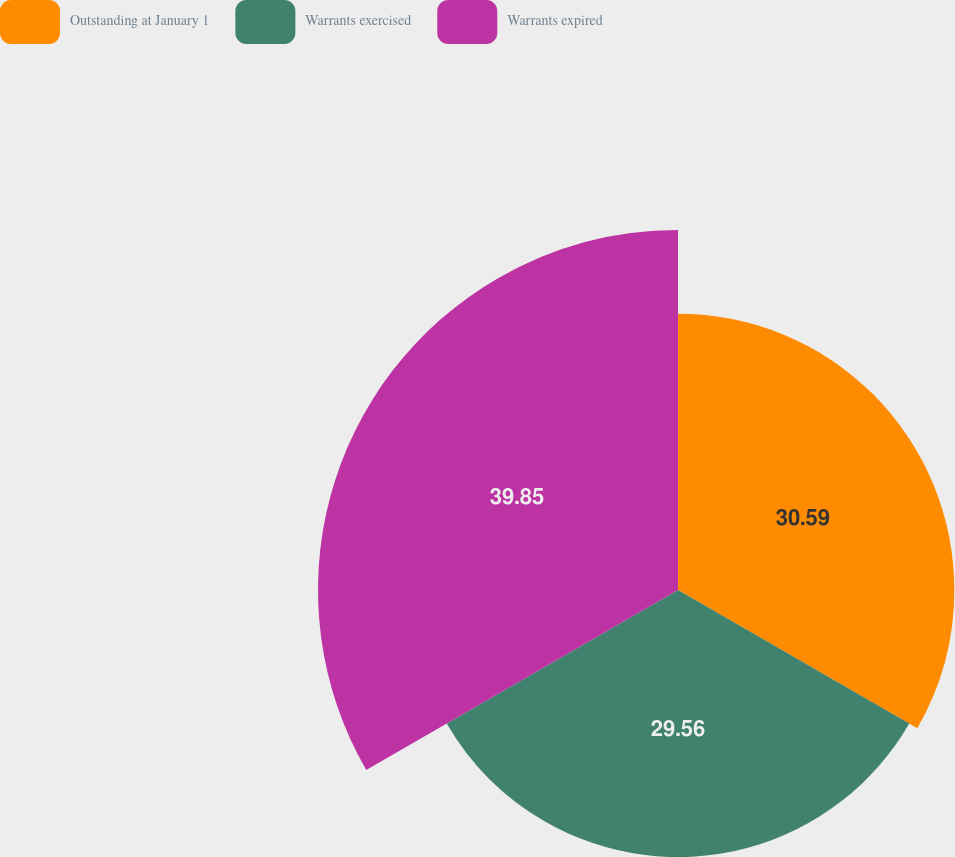Convert chart to OTSL. <chart><loc_0><loc_0><loc_500><loc_500><pie_chart><fcel>Outstanding at January 1<fcel>Warrants exercised<fcel>Warrants expired<nl><fcel>30.59%<fcel>29.56%<fcel>39.85%<nl></chart> 